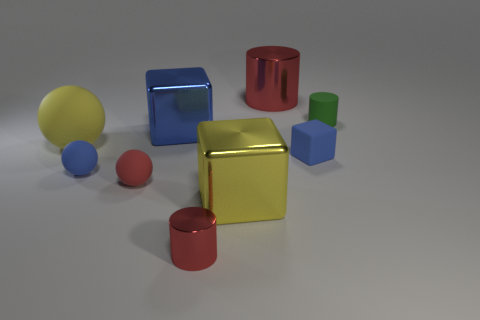Subtract all tiny green rubber cylinders. How many cylinders are left? 2 Subtract all green cylinders. How many cylinders are left? 2 Subtract all green cylinders. How many blue blocks are left? 2 Subtract all brown metallic cubes. Subtract all small red balls. How many objects are left? 8 Add 1 tiny blue blocks. How many tiny blue blocks are left? 2 Add 1 cyan things. How many cyan things exist? 1 Subtract 1 green cylinders. How many objects are left? 8 Subtract all balls. How many objects are left? 6 Subtract all cyan balls. Subtract all green cylinders. How many balls are left? 3 